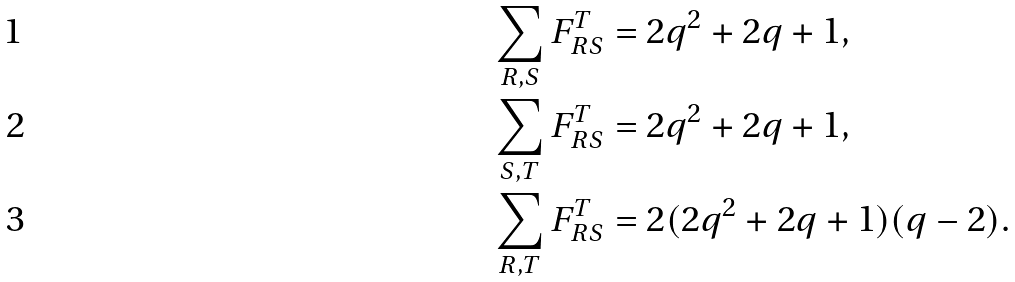<formula> <loc_0><loc_0><loc_500><loc_500>\sum _ { R , S } F _ { R S } ^ { T } & = 2 q ^ { 2 } + 2 q + 1 , \\ \sum _ { S , T } F _ { R S } ^ { T } & = 2 q ^ { 2 } + 2 q + 1 , \\ \sum _ { R , T } F _ { R S } ^ { T } & = 2 ( 2 q ^ { 2 } + 2 q + 1 ) ( q - 2 ) .</formula> 